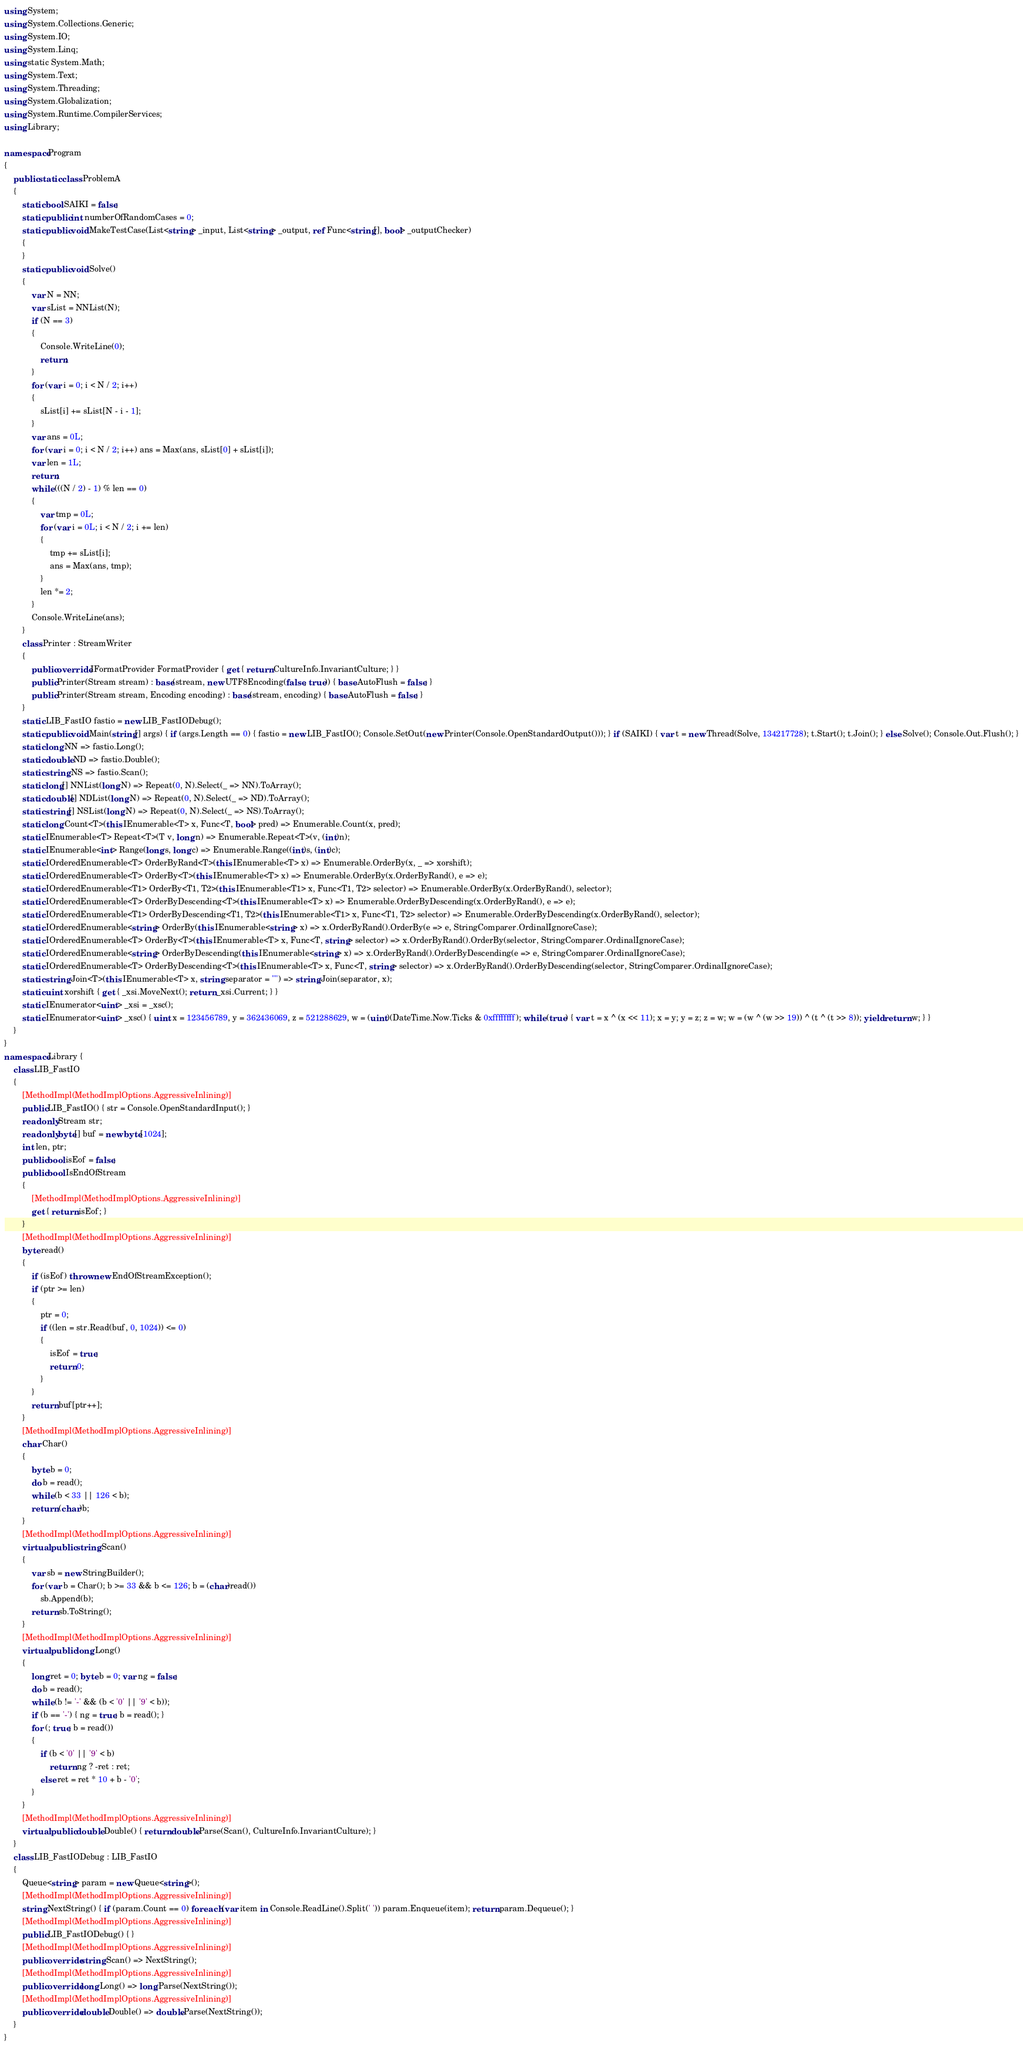Convert code to text. <code><loc_0><loc_0><loc_500><loc_500><_C#_>using System;
using System.Collections.Generic;
using System.IO;
using System.Linq;
using static System.Math;
using System.Text;
using System.Threading;
using System.Globalization;
using System.Runtime.CompilerServices;
using Library;

namespace Program
{
    public static class ProblemA
    {
        static bool SAIKI = false;
        static public int numberOfRandomCases = 0;
        static public void MakeTestCase(List<string> _input, List<string> _output, ref Func<string[], bool> _outputChecker)
        {
        }
        static public void Solve()
        {
            var N = NN;
            var sList = NNList(N);
            if (N == 3)
            {
                Console.WriteLine(0);
                return;
            }
            for (var i = 0; i < N / 2; i++)
            {
                sList[i] += sList[N - i - 1];
            }
            var ans = 0L;
            for (var i = 0; i < N / 2; i++) ans = Max(ans, sList[0] + sList[i]);
            var len = 1L;
            return;
            while (((N / 2) - 1) % len == 0)
            {
                var tmp = 0L;
                for (var i = 0L; i < N / 2; i += len)
                {
                    tmp += sList[i];
                    ans = Max(ans, tmp);
                }
                len *= 2;
            }
            Console.WriteLine(ans);
        }
        class Printer : StreamWriter
        {
            public override IFormatProvider FormatProvider { get { return CultureInfo.InvariantCulture; } }
            public Printer(Stream stream) : base(stream, new UTF8Encoding(false, true)) { base.AutoFlush = false; }
            public Printer(Stream stream, Encoding encoding) : base(stream, encoding) { base.AutoFlush = false; }
        }
        static LIB_FastIO fastio = new LIB_FastIODebug();
        static public void Main(string[] args) { if (args.Length == 0) { fastio = new LIB_FastIO(); Console.SetOut(new Printer(Console.OpenStandardOutput())); } if (SAIKI) { var t = new Thread(Solve, 134217728); t.Start(); t.Join(); } else Solve(); Console.Out.Flush(); }
        static long NN => fastio.Long();
        static double ND => fastio.Double();
        static string NS => fastio.Scan();
        static long[] NNList(long N) => Repeat(0, N).Select(_ => NN).ToArray();
        static double[] NDList(long N) => Repeat(0, N).Select(_ => ND).ToArray();
        static string[] NSList(long N) => Repeat(0, N).Select(_ => NS).ToArray();
        static long Count<T>(this IEnumerable<T> x, Func<T, bool> pred) => Enumerable.Count(x, pred);
        static IEnumerable<T> Repeat<T>(T v, long n) => Enumerable.Repeat<T>(v, (int)n);
        static IEnumerable<int> Range(long s, long c) => Enumerable.Range((int)s, (int)c);
        static IOrderedEnumerable<T> OrderByRand<T>(this IEnumerable<T> x) => Enumerable.OrderBy(x, _ => xorshift);
        static IOrderedEnumerable<T> OrderBy<T>(this IEnumerable<T> x) => Enumerable.OrderBy(x.OrderByRand(), e => e);
        static IOrderedEnumerable<T1> OrderBy<T1, T2>(this IEnumerable<T1> x, Func<T1, T2> selector) => Enumerable.OrderBy(x.OrderByRand(), selector);
        static IOrderedEnumerable<T> OrderByDescending<T>(this IEnumerable<T> x) => Enumerable.OrderByDescending(x.OrderByRand(), e => e);
        static IOrderedEnumerable<T1> OrderByDescending<T1, T2>(this IEnumerable<T1> x, Func<T1, T2> selector) => Enumerable.OrderByDescending(x.OrderByRand(), selector);
        static IOrderedEnumerable<string> OrderBy(this IEnumerable<string> x) => x.OrderByRand().OrderBy(e => e, StringComparer.OrdinalIgnoreCase);
        static IOrderedEnumerable<T> OrderBy<T>(this IEnumerable<T> x, Func<T, string> selector) => x.OrderByRand().OrderBy(selector, StringComparer.OrdinalIgnoreCase);
        static IOrderedEnumerable<string> OrderByDescending(this IEnumerable<string> x) => x.OrderByRand().OrderByDescending(e => e, StringComparer.OrdinalIgnoreCase);
        static IOrderedEnumerable<T> OrderByDescending<T>(this IEnumerable<T> x, Func<T, string> selector) => x.OrderByRand().OrderByDescending(selector, StringComparer.OrdinalIgnoreCase);
        static string Join<T>(this IEnumerable<T> x, string separator = "") => string.Join(separator, x);
        static uint xorshift { get { _xsi.MoveNext(); return _xsi.Current; } }
        static IEnumerator<uint> _xsi = _xsc();
        static IEnumerator<uint> _xsc() { uint x = 123456789, y = 362436069, z = 521288629, w = (uint)(DateTime.Now.Ticks & 0xffffffff); while (true) { var t = x ^ (x << 11); x = y; y = z; z = w; w = (w ^ (w >> 19)) ^ (t ^ (t >> 8)); yield return w; } }
    }
}
namespace Library {
    class LIB_FastIO
    {
        [MethodImpl(MethodImplOptions.AggressiveInlining)]
        public LIB_FastIO() { str = Console.OpenStandardInput(); }
        readonly Stream str;
        readonly byte[] buf = new byte[1024];
        int len, ptr;
        public bool isEof = false;
        public bool IsEndOfStream
        {
            [MethodImpl(MethodImplOptions.AggressiveInlining)]
            get { return isEof; }
        }
        [MethodImpl(MethodImplOptions.AggressiveInlining)]
        byte read()
        {
            if (isEof) throw new EndOfStreamException();
            if (ptr >= len)
            {
                ptr = 0;
                if ((len = str.Read(buf, 0, 1024)) <= 0)
                {
                    isEof = true;
                    return 0;
                }
            }
            return buf[ptr++];
        }
        [MethodImpl(MethodImplOptions.AggressiveInlining)]
        char Char()
        {
            byte b = 0;
            do b = read();
            while (b < 33 || 126 < b);
            return (char)b;
        }
        [MethodImpl(MethodImplOptions.AggressiveInlining)]
        virtual public string Scan()
        {
            var sb = new StringBuilder();
            for (var b = Char(); b >= 33 && b <= 126; b = (char)read())
                sb.Append(b);
            return sb.ToString();
        }
        [MethodImpl(MethodImplOptions.AggressiveInlining)]
        virtual public long Long()
        {
            long ret = 0; byte b = 0; var ng = false;
            do b = read();
            while (b != '-' && (b < '0' || '9' < b));
            if (b == '-') { ng = true; b = read(); }
            for (; true; b = read())
            {
                if (b < '0' || '9' < b)
                    return ng ? -ret : ret;
                else ret = ret * 10 + b - '0';
            }
        }
        [MethodImpl(MethodImplOptions.AggressiveInlining)]
        virtual public double Double() { return double.Parse(Scan(), CultureInfo.InvariantCulture); }
    }
    class LIB_FastIODebug : LIB_FastIO
    {
        Queue<string> param = new Queue<string>();
        [MethodImpl(MethodImplOptions.AggressiveInlining)]
        string NextString() { if (param.Count == 0) foreach (var item in Console.ReadLine().Split(' ')) param.Enqueue(item); return param.Dequeue(); }
        [MethodImpl(MethodImplOptions.AggressiveInlining)]
        public LIB_FastIODebug() { }
        [MethodImpl(MethodImplOptions.AggressiveInlining)]
        public override string Scan() => NextString();
        [MethodImpl(MethodImplOptions.AggressiveInlining)]
        public override long Long() => long.Parse(NextString());
        [MethodImpl(MethodImplOptions.AggressiveInlining)]
        public override double Double() => double.Parse(NextString());
    }
}
</code> 